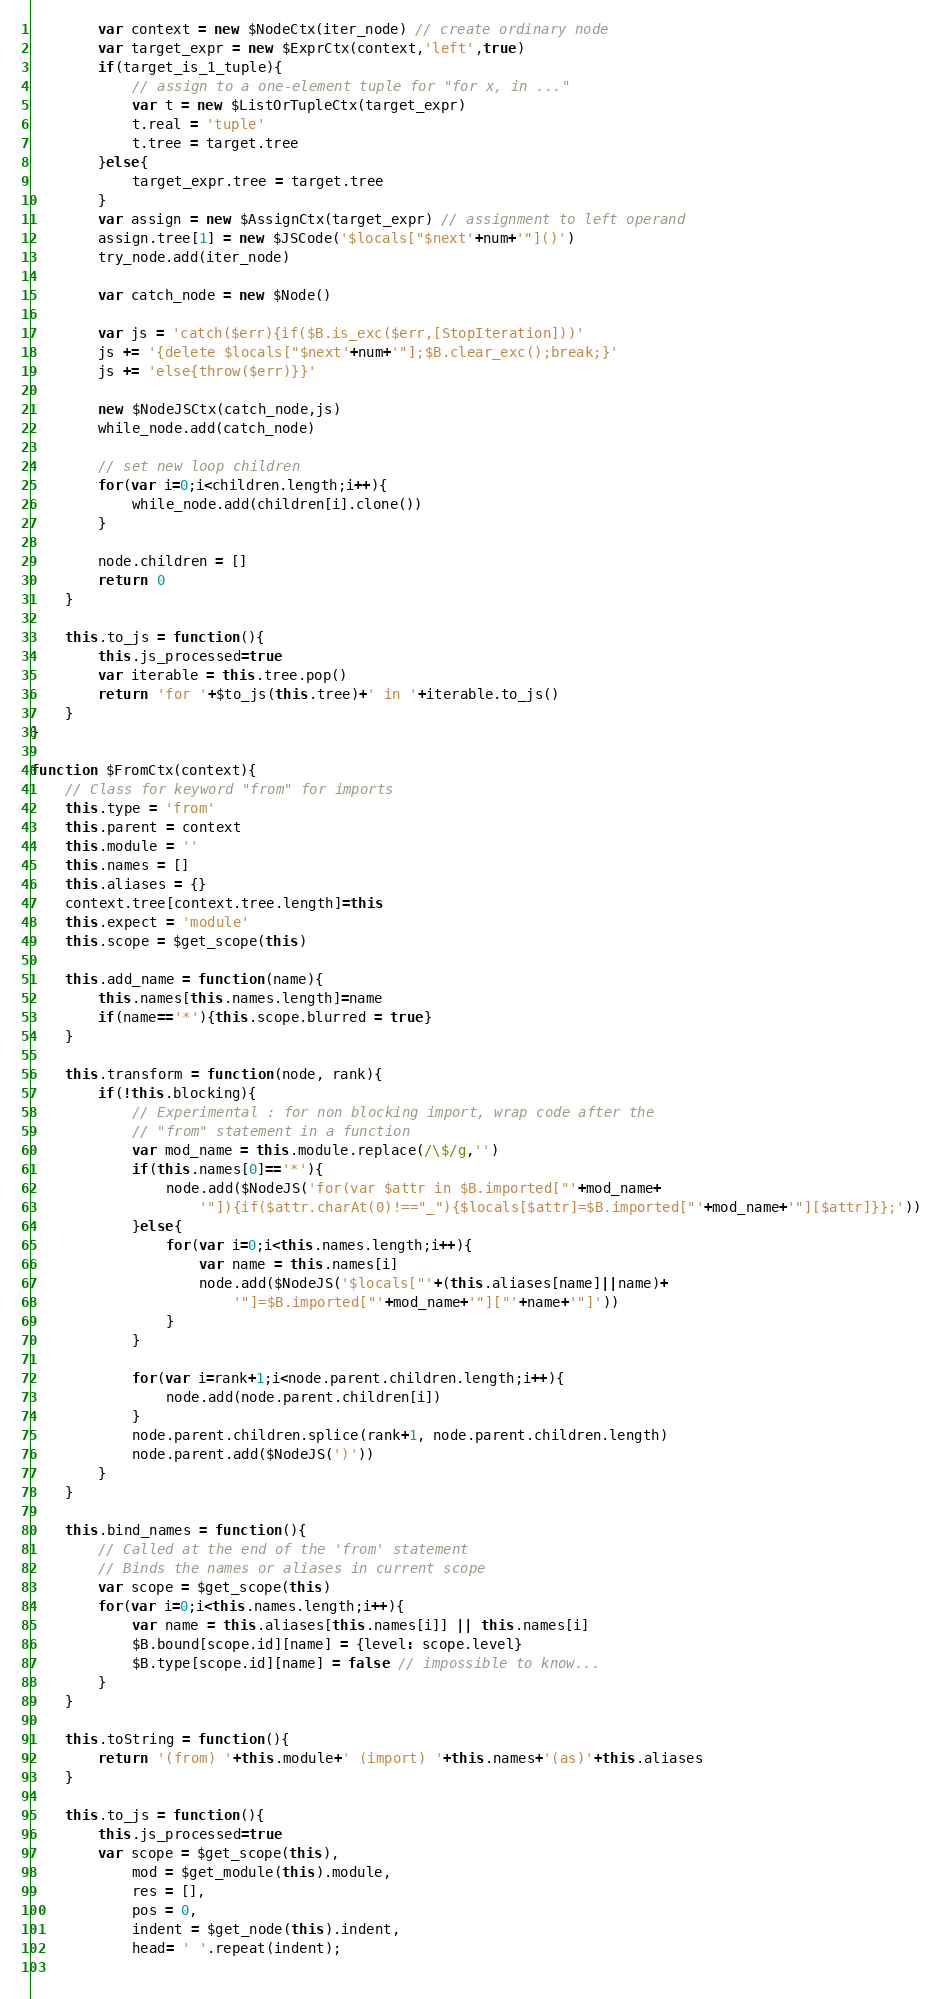<code> <loc_0><loc_0><loc_500><loc_500><_JavaScript_>        var context = new $NodeCtx(iter_node) // create ordinary node
        var target_expr = new $ExprCtx(context,'left',true)
        if(target_is_1_tuple){
            // assign to a one-element tuple for "for x, in ..."
            var t = new $ListOrTupleCtx(target_expr)
            t.real = 'tuple'
            t.tree = target.tree
        }else{
            target_expr.tree = target.tree
        }
        var assign = new $AssignCtx(target_expr) // assignment to left operand
        assign.tree[1] = new $JSCode('$locals["$next'+num+'"]()')
        try_node.add(iter_node)

        var catch_node = new $Node()

        var js = 'catch($err){if($B.is_exc($err,[StopIteration]))'
        js += '{delete $locals["$next'+num+'"];$B.clear_exc();break;}'
        js += 'else{throw($err)}}'        

        new $NodeJSCtx(catch_node,js)
        while_node.add(catch_node)
        
        // set new loop children
        for(var i=0;i<children.length;i++){
            while_node.add(children[i].clone())
        }

        node.children = []
        return 0
    }

    this.to_js = function(){
        this.js_processed=true
        var iterable = this.tree.pop()
        return 'for '+$to_js(this.tree)+' in '+iterable.to_js()
    }
}

function $FromCtx(context){
    // Class for keyword "from" for imports
    this.type = 'from'
    this.parent = context
    this.module = ''
    this.names = []
    this.aliases = {}
    context.tree[context.tree.length]=this
    this.expect = 'module'
    this.scope = $get_scope(this)

    this.add_name = function(name){
        this.names[this.names.length]=name
        if(name=='*'){this.scope.blurred = true}
    }
    
    this.transform = function(node, rank){
        if(!this.blocking){
            // Experimental : for non blocking import, wrap code after the
            // "from" statement in a function
            var mod_name = this.module.replace(/\$/g,'')
            if(this.names[0]=='*'){
                node.add($NodeJS('for(var $attr in $B.imported["'+mod_name+
                    '"]){if($attr.charAt(0)!=="_"){$locals[$attr]=$B.imported["'+mod_name+'"][$attr]}};'))
            }else{
                for(var i=0;i<this.names.length;i++){
                    var name = this.names[i]
                    node.add($NodeJS('$locals["'+(this.aliases[name]||name)+
                        '"]=$B.imported["'+mod_name+'"]["'+name+'"]'))
                }
            }

            for(var i=rank+1;i<node.parent.children.length;i++){
                node.add(node.parent.children[i])
            }
            node.parent.children.splice(rank+1, node.parent.children.length)
            node.parent.add($NodeJS(')'))
        }
    }
    
    this.bind_names = function(){
        // Called at the end of the 'from' statement
        // Binds the names or aliases in current scope
        var scope = $get_scope(this)
        for(var i=0;i<this.names.length;i++){
            var name = this.aliases[this.names[i]] || this.names[i]
            $B.bound[scope.id][name] = {level: scope.level}
            $B.type[scope.id][name] = false // impossible to know...
        }
    }
    
    this.toString = function(){
        return '(from) '+this.module+' (import) '+this.names+'(as)'+this.aliases
    }
    
    this.to_js = function(){
        this.js_processed=true
        var scope = $get_scope(this),
            mod = $get_module(this).module,
            res = [],
            pos = 0,
            indent = $get_node(this).indent,
            head= ' '.repeat(indent);
        </code> 